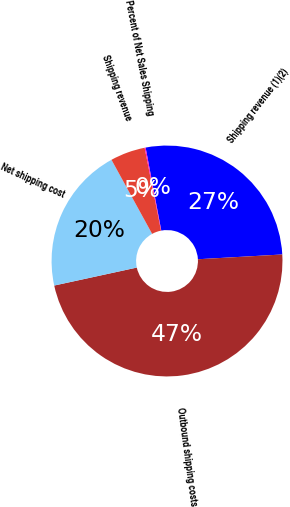Convert chart to OTSL. <chart><loc_0><loc_0><loc_500><loc_500><pie_chart><fcel>Shipping revenue (1)(2)<fcel>Outbound shipping costs<fcel>Net shipping cost<fcel>Shipping revenue<fcel>Percent of Net Sales Shipping<nl><fcel>27.07%<fcel>47.49%<fcel>20.42%<fcel>4.88%<fcel>0.14%<nl></chart> 